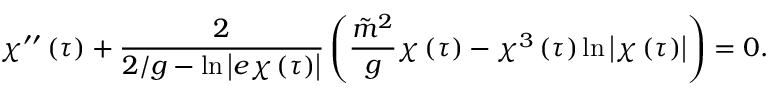<formula> <loc_0><loc_0><loc_500><loc_500>\chi ^ { \prime \prime } \left ( \tau \right ) + \frac { 2 } { 2 / g - \ln \left | e \chi \left ( \tau \right ) \right | } \left ( \frac { \tilde { m } ^ { 2 } } { g } \chi \left ( \tau \right ) - \chi ^ { 3 } \left ( \tau \right ) \ln \left | \chi \left ( \tau \right ) \right | \right ) = 0 .</formula> 